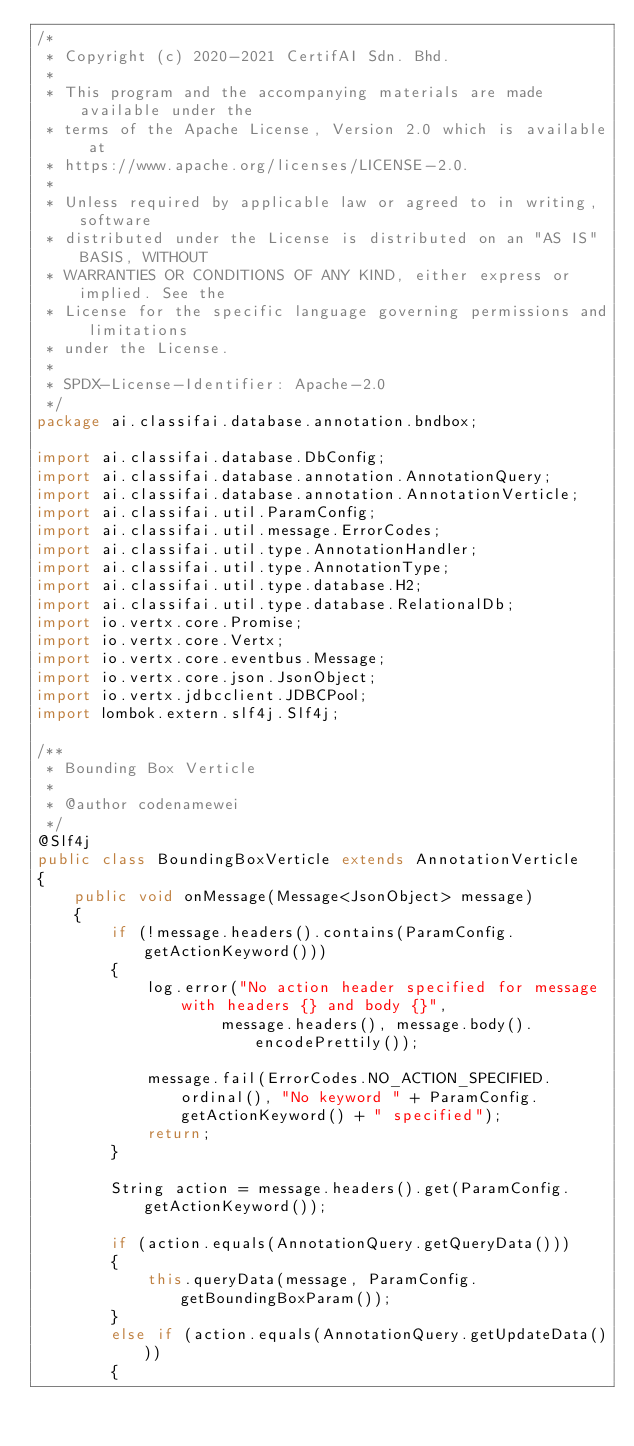Convert code to text. <code><loc_0><loc_0><loc_500><loc_500><_Java_>/*
 * Copyright (c) 2020-2021 CertifAI Sdn. Bhd.
 *
 * This program and the accompanying materials are made available under the
 * terms of the Apache License, Version 2.0 which is available at
 * https://www.apache.org/licenses/LICENSE-2.0.
 *
 * Unless required by applicable law or agreed to in writing, software
 * distributed under the License is distributed on an "AS IS" BASIS, WITHOUT
 * WARRANTIES OR CONDITIONS OF ANY KIND, either express or implied. See the
 * License for the specific language governing permissions and limitations
 * under the License.
 *
 * SPDX-License-Identifier: Apache-2.0
 */
package ai.classifai.database.annotation.bndbox;

import ai.classifai.database.DbConfig;
import ai.classifai.database.annotation.AnnotationQuery;
import ai.classifai.database.annotation.AnnotationVerticle;
import ai.classifai.util.ParamConfig;
import ai.classifai.util.message.ErrorCodes;
import ai.classifai.util.type.AnnotationHandler;
import ai.classifai.util.type.AnnotationType;
import ai.classifai.util.type.database.H2;
import ai.classifai.util.type.database.RelationalDb;
import io.vertx.core.Promise;
import io.vertx.core.Vertx;
import io.vertx.core.eventbus.Message;
import io.vertx.core.json.JsonObject;
import io.vertx.jdbcclient.JDBCPool;
import lombok.extern.slf4j.Slf4j;

/**
 * Bounding Box Verticle
 *
 * @author codenamewei
 */
@Slf4j
public class BoundingBoxVerticle extends AnnotationVerticle
{
    public void onMessage(Message<JsonObject> message)
    {
        if (!message.headers().contains(ParamConfig.getActionKeyword()))
        {
            log.error("No action header specified for message with headers {} and body {}",
                    message.headers(), message.body().encodePrettily());

            message.fail(ErrorCodes.NO_ACTION_SPECIFIED.ordinal(), "No keyword " + ParamConfig.getActionKeyword() + " specified");
            return;
        }

        String action = message.headers().get(ParamConfig.getActionKeyword());

        if (action.equals(AnnotationQuery.getQueryData()))
        {
            this.queryData(message, ParamConfig.getBoundingBoxParam());
        }
        else if (action.equals(AnnotationQuery.getUpdateData()))
        {</code> 